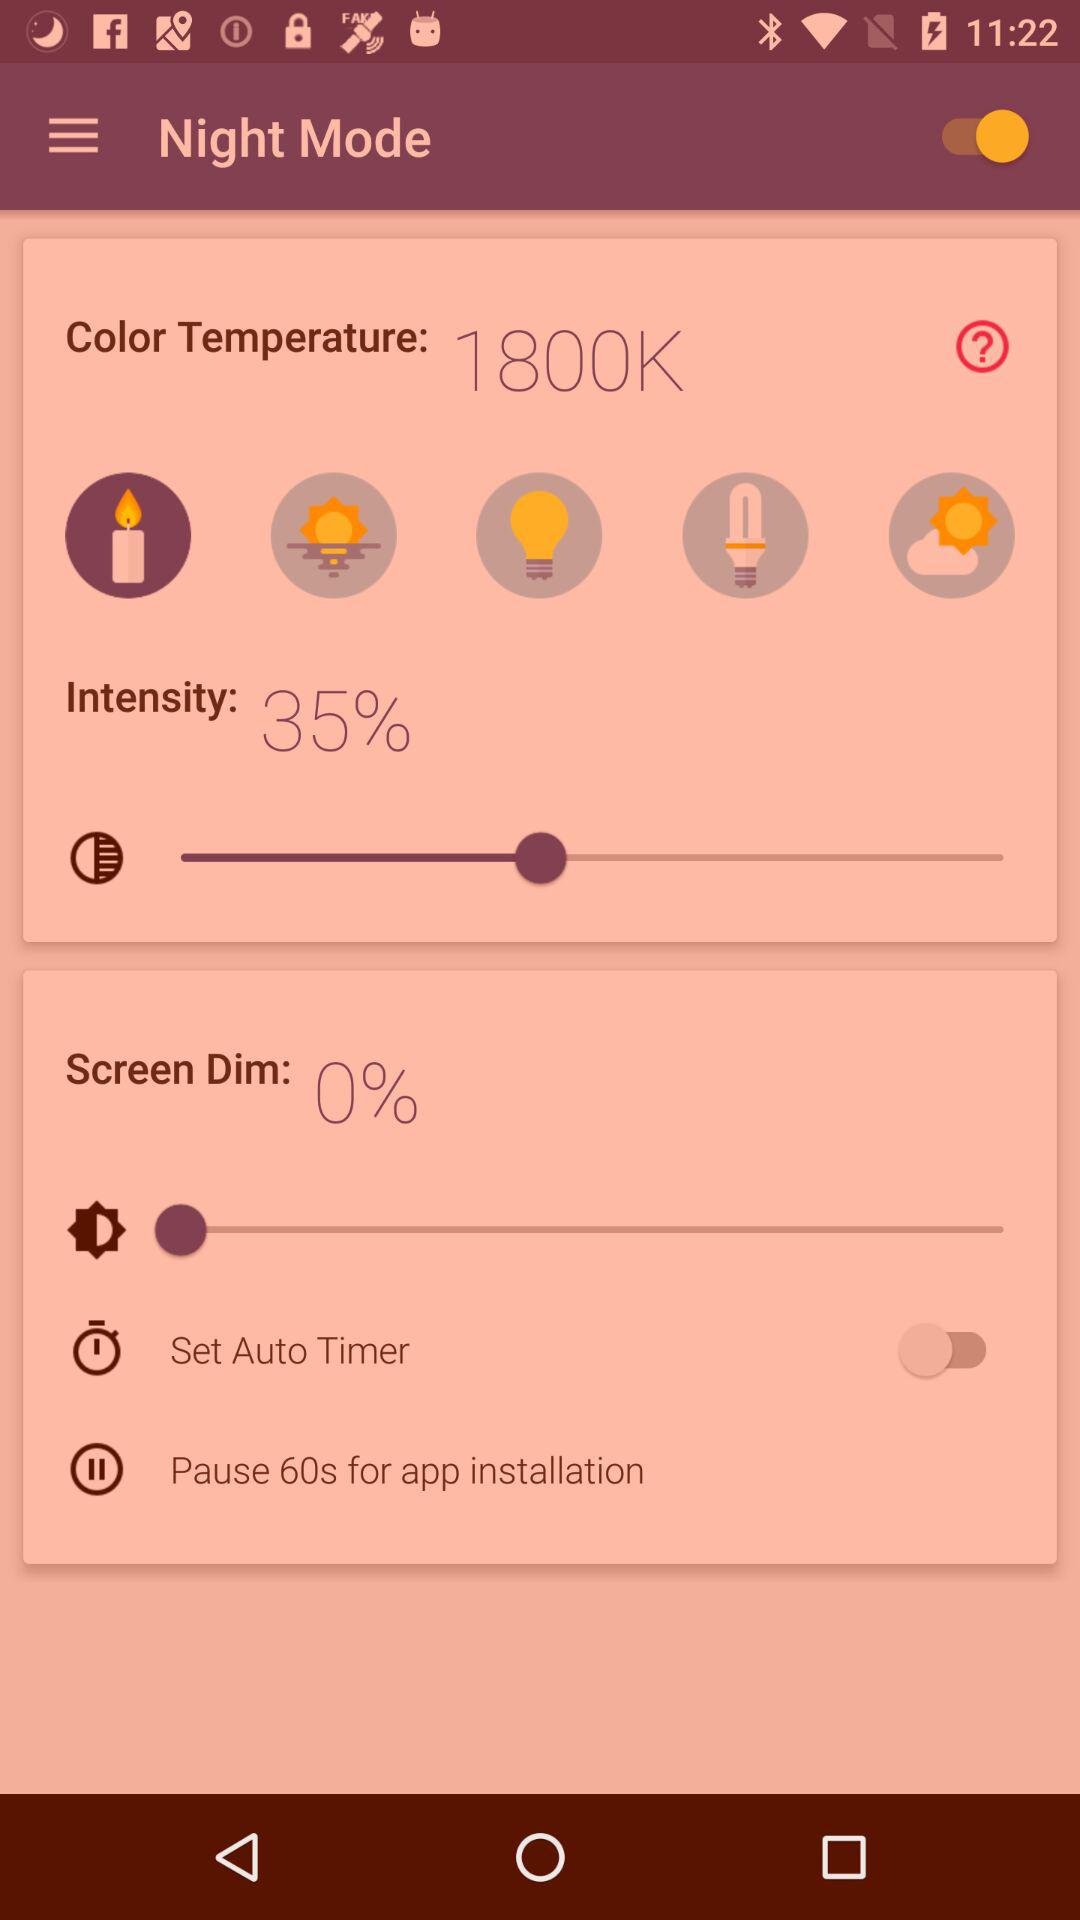How much is the intensity? The intensity is 35%. 